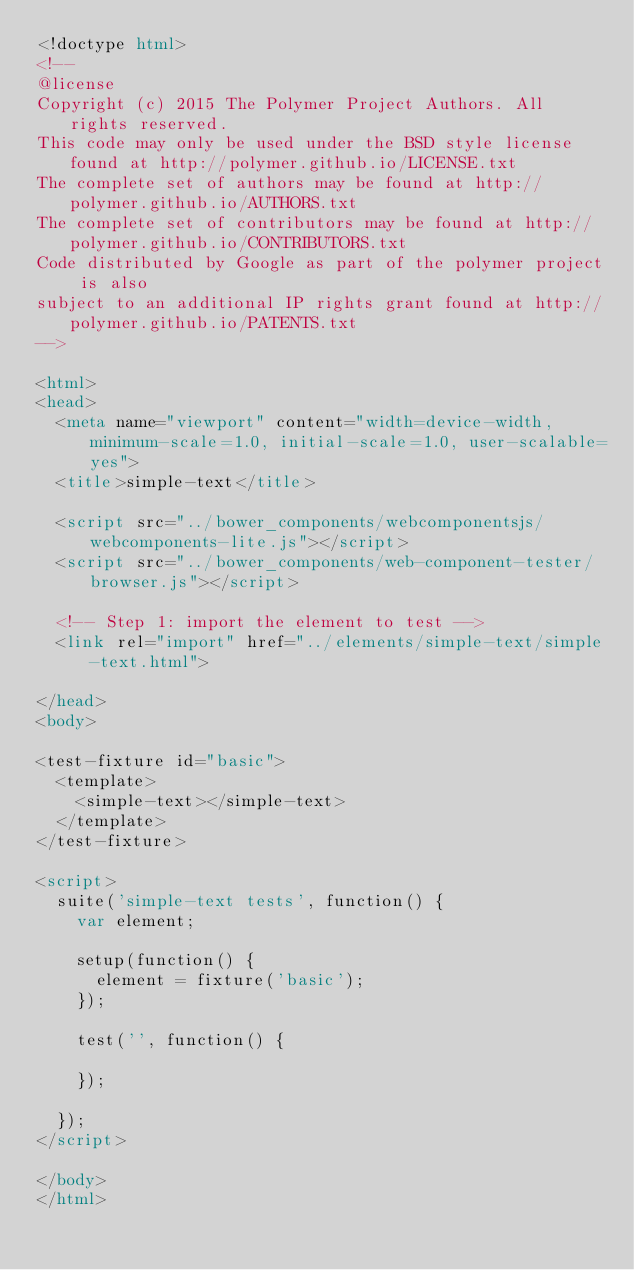<code> <loc_0><loc_0><loc_500><loc_500><_HTML_><!doctype html>
<!--
@license
Copyright (c) 2015 The Polymer Project Authors. All rights reserved.
This code may only be used under the BSD style license found at http://polymer.github.io/LICENSE.txt
The complete set of authors may be found at http://polymer.github.io/AUTHORS.txt
The complete set of contributors may be found at http://polymer.github.io/CONTRIBUTORS.txt
Code distributed by Google as part of the polymer project is also
subject to an additional IP rights grant found at http://polymer.github.io/PATENTS.txt
-->

<html>
<head>
  <meta name="viewport" content="width=device-width, minimum-scale=1.0, initial-scale=1.0, user-scalable=yes">
  <title>simple-text</title>

  <script src="../bower_components/webcomponentsjs/webcomponents-lite.js"></script>
  <script src="../bower_components/web-component-tester/browser.js"></script>

  <!-- Step 1: import the element to test -->
  <link rel="import" href="../elements/simple-text/simple-text.html">

</head>
<body>

<test-fixture id="basic">
  <template>
    <simple-text></simple-text>
  </template>
</test-fixture>

<script>
  suite('simple-text tests', function() {
    var element;

    setup(function() {
      element = fixture('basic');
    });

    test('', function() {

    });

  });
</script>

</body>
</html>
</code> 